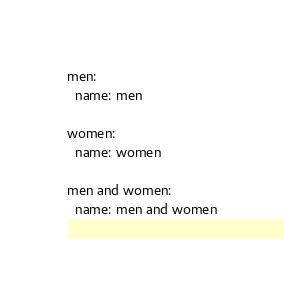<code> <loc_0><loc_0><loc_500><loc_500><_YAML_>men:
  name: men

women:
  name: women

men and women:
  name: men and women
</code> 